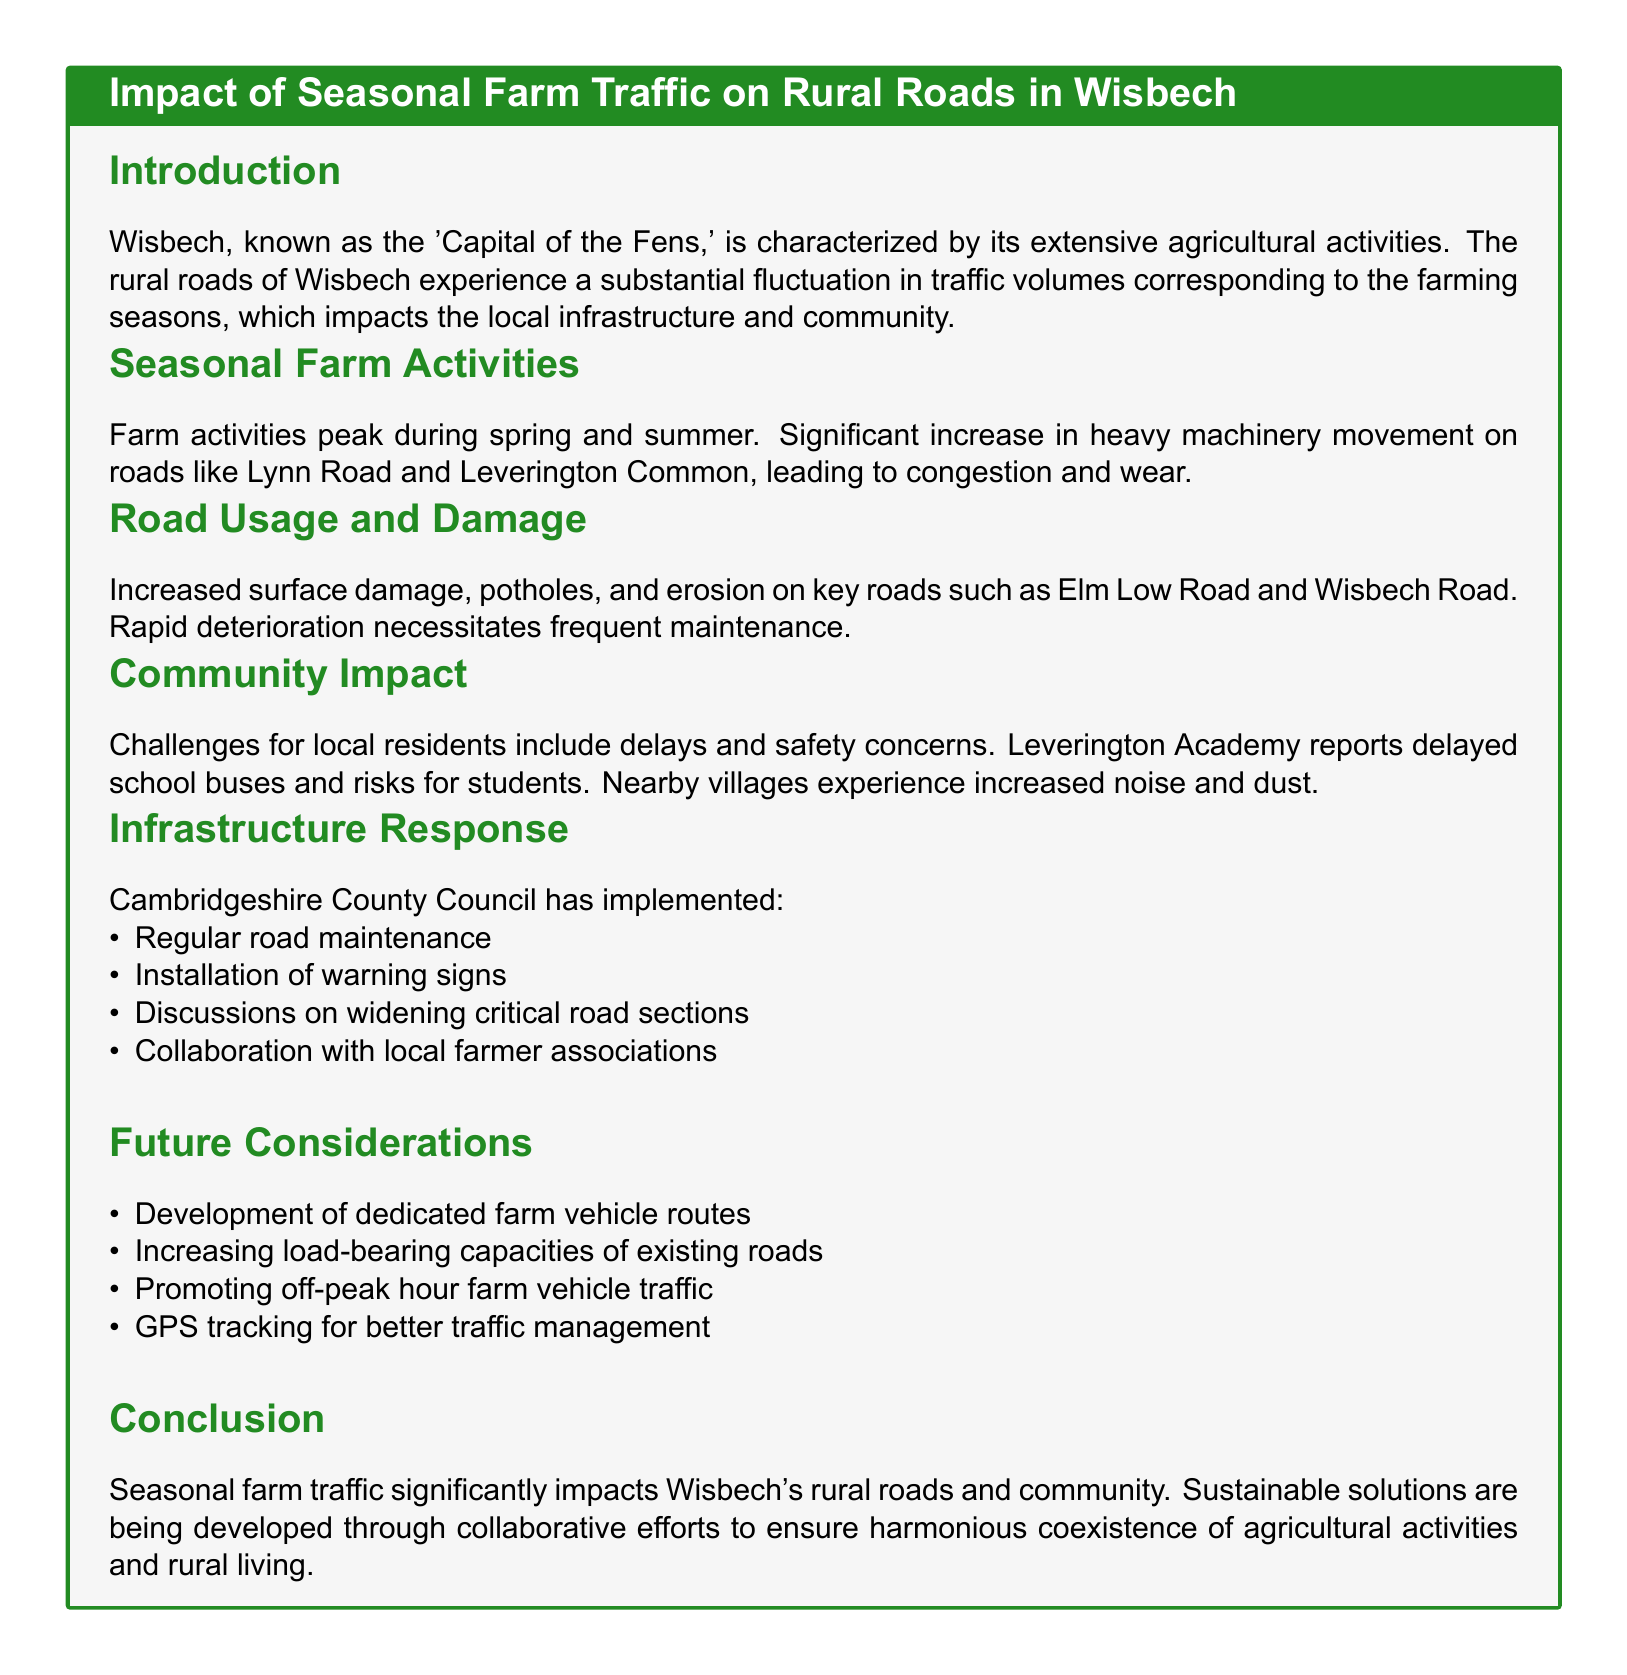What is Wisbech known as? Wisbech is characterized by its extensive agricultural activities, referred to as the 'Capital of the Fens.'
Answer: Capital of the Fens What roads experience substantial farm traffic? The report mentions significant increases in heavy machinery movement on roads like Lynn Road and Leverington Common.
Answer: Lynn Road and Leverington Common Which road is mentioned for increased surface damage? The document specifically highlights increased surface damage on Elm Low Road and Wisbech Road.
Answer: Elm Low Road and Wisbech Road What challenge do local residents face regarding school buses? Leverington Academy reports delayed school buses due to increased farm traffic.
Answer: Delays Who has implemented road maintenance measures? Cambridgeshire County Council is responsible for implementing regular road maintenance and other measures.
Answer: Cambridgeshire County Council What is a future consideration mentioned for traffic management? Future considerations include the development of dedicated farm vehicle routes for better traffic management.
Answer: Dedicated farm vehicle routes What does the document suggest for promoting farm vehicle traffic? It suggests promoting off-peak hour farm vehicle traffic as a solution for managing congestion.
Answer: Off-peak hour traffic What kind of community impact is reported? Increased noise and dust are reported as significant impacts on nearby villages due to farm activities.
Answer: Noise and dust 